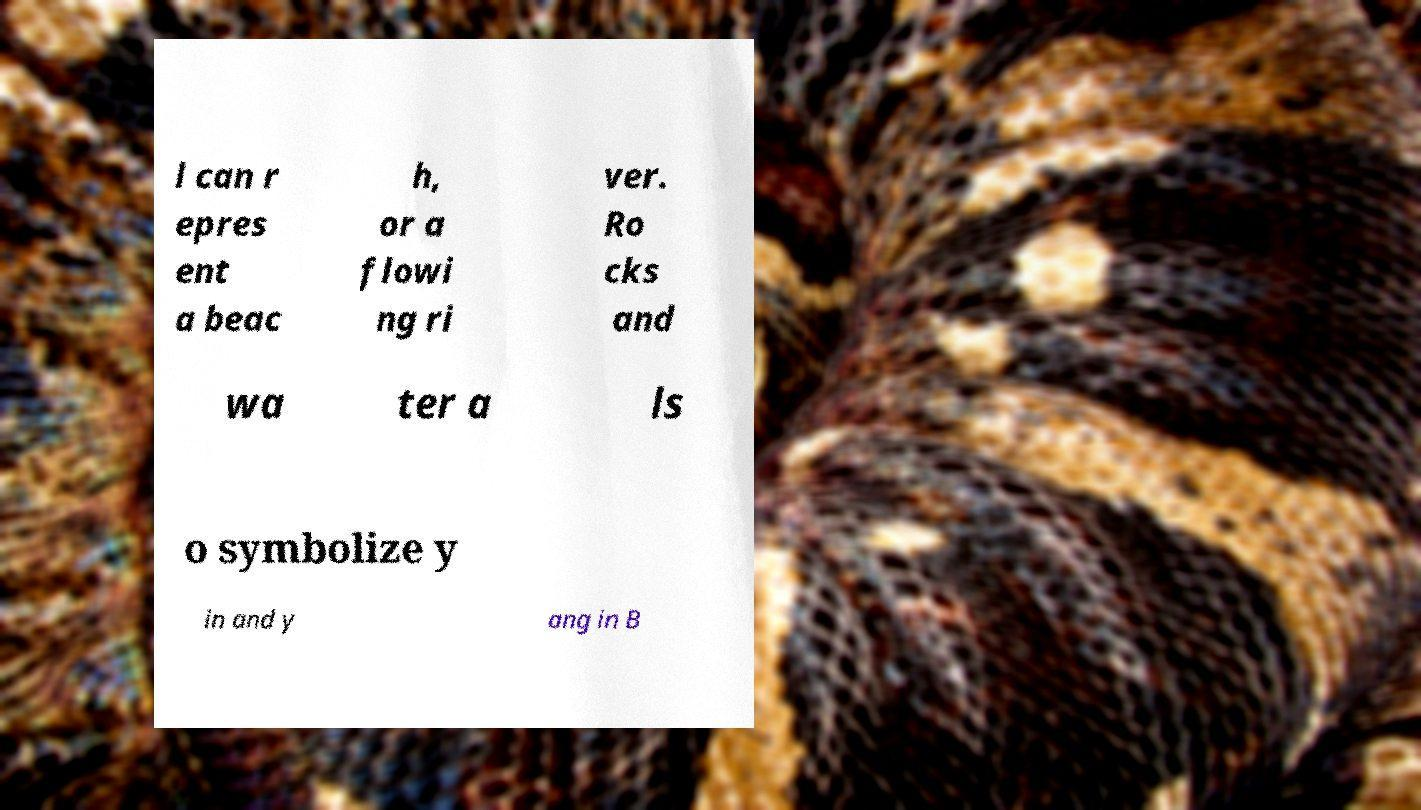What messages or text are displayed in this image? I need them in a readable, typed format. l can r epres ent a beac h, or a flowi ng ri ver. Ro cks and wa ter a ls o symbolize y in and y ang in B 